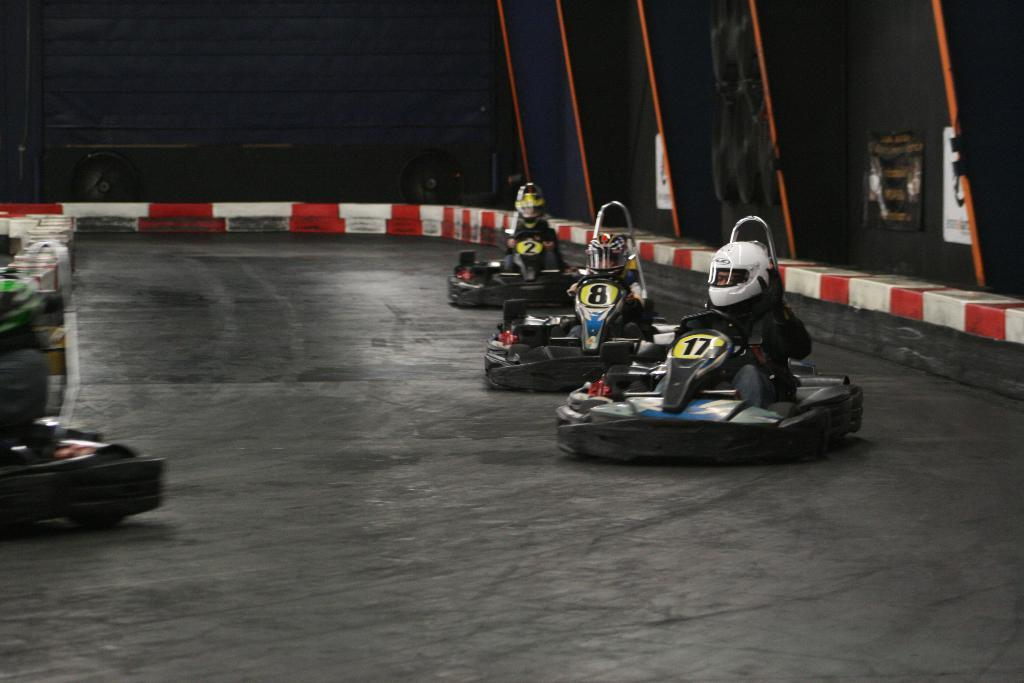What are the people in the image doing? The people are sitting on go karting vehicles. Where are the go karting vehicles located? The go karting vehicles are on the ground. What can be seen in the background of the image? There are posters, a wall, a trolley, and some objects visible in the background of the image. What type of corn can be seen growing in the image? There is no corn present in the image. What sound can be heard coming from the flag in the image? There is no flag present in the image, and therefore no sound can be heard from it. 